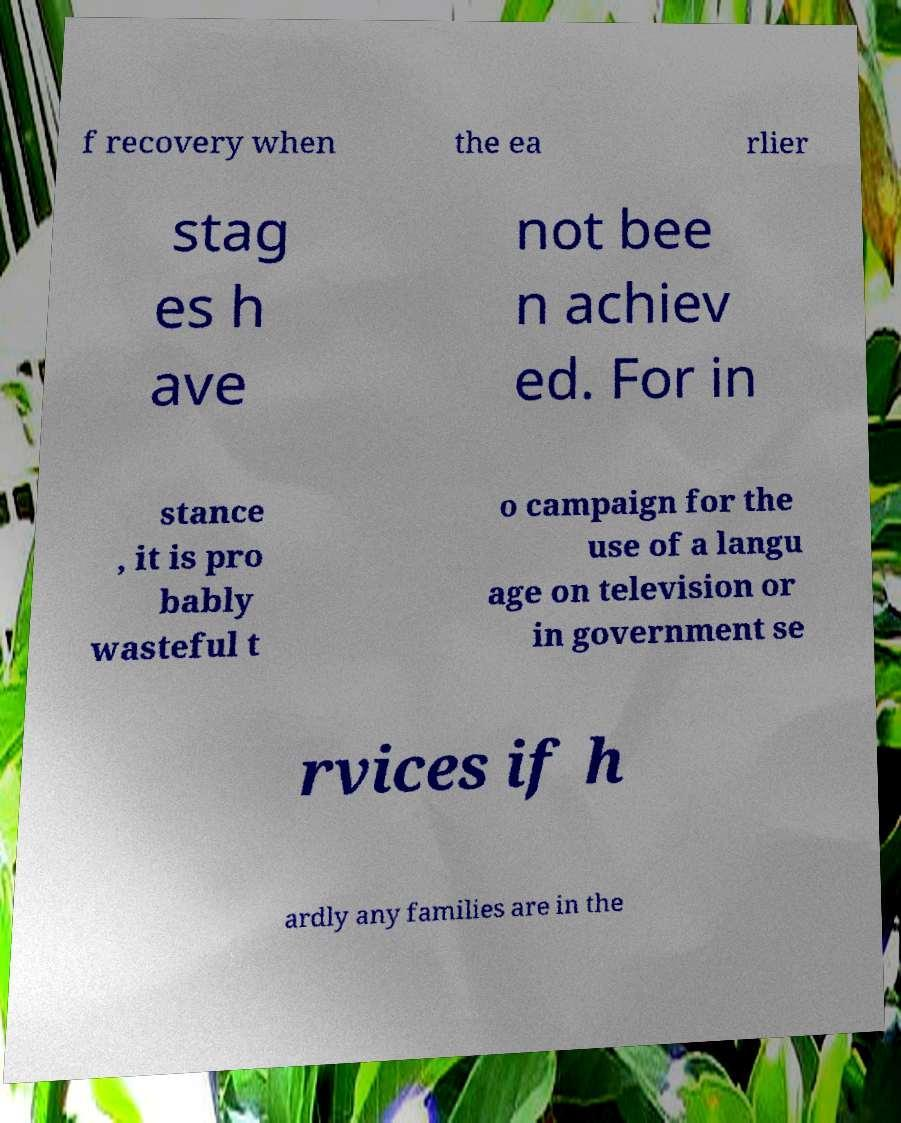I need the written content from this picture converted into text. Can you do that? f recovery when the ea rlier stag es h ave not bee n achiev ed. For in stance , it is pro bably wasteful t o campaign for the use of a langu age on television or in government se rvices if h ardly any families are in the 